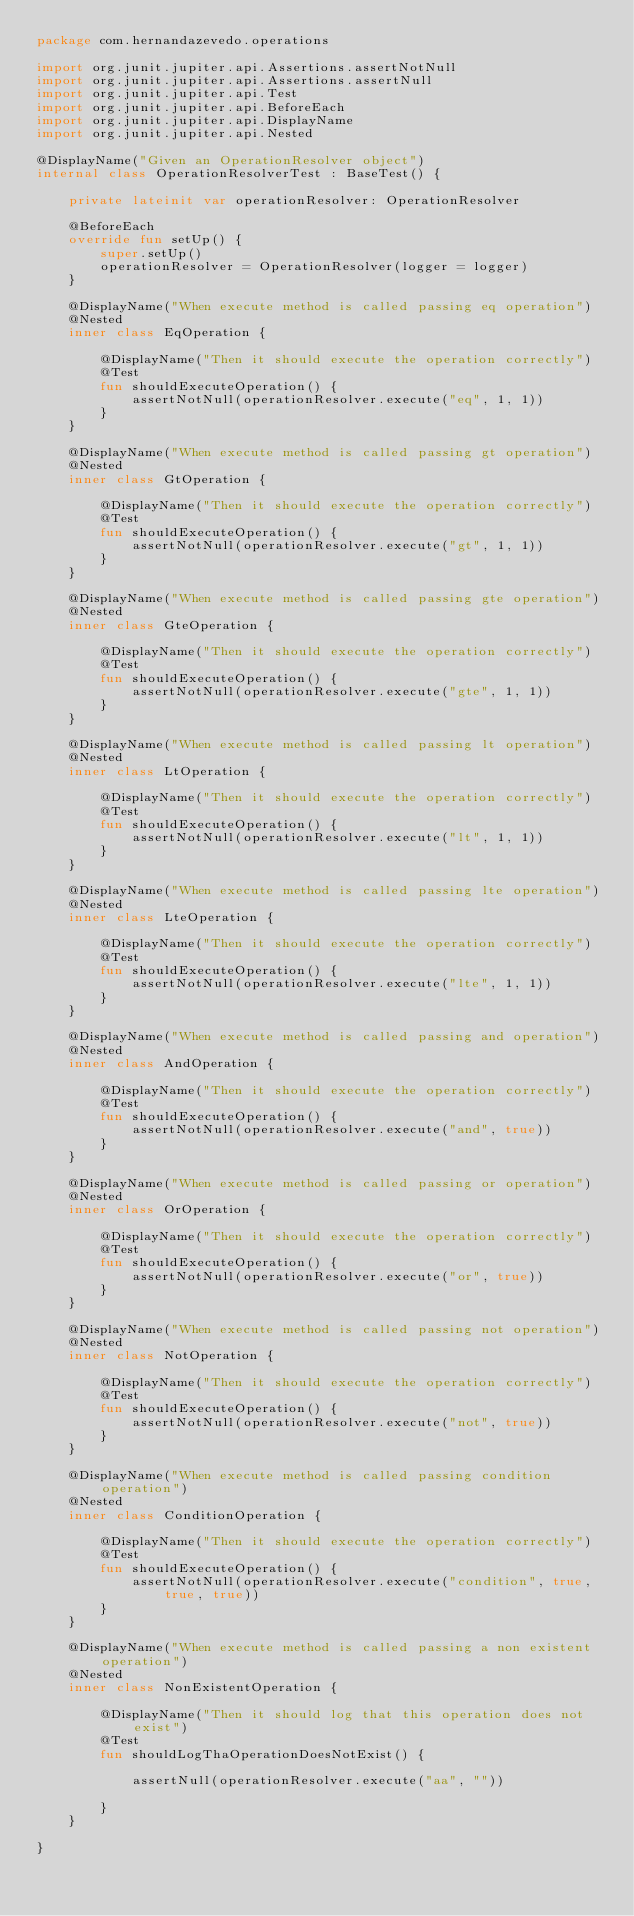<code> <loc_0><loc_0><loc_500><loc_500><_Kotlin_>package com.hernandazevedo.operations

import org.junit.jupiter.api.Assertions.assertNotNull
import org.junit.jupiter.api.Assertions.assertNull
import org.junit.jupiter.api.Test
import org.junit.jupiter.api.BeforeEach
import org.junit.jupiter.api.DisplayName
import org.junit.jupiter.api.Nested

@DisplayName("Given an OperationResolver object")
internal class OperationResolverTest : BaseTest() {

    private lateinit var operationResolver: OperationResolver

    @BeforeEach
    override fun setUp() {
        super.setUp()
        operationResolver = OperationResolver(logger = logger)
    }

    @DisplayName("When execute method is called passing eq operation")
    @Nested
    inner class EqOperation {

        @DisplayName("Then it should execute the operation correctly")
        @Test
        fun shouldExecuteOperation() {
            assertNotNull(operationResolver.execute("eq", 1, 1))
        }
    }

    @DisplayName("When execute method is called passing gt operation")
    @Nested
    inner class GtOperation {

        @DisplayName("Then it should execute the operation correctly")
        @Test
        fun shouldExecuteOperation() {
            assertNotNull(operationResolver.execute("gt", 1, 1))
        }
    }

    @DisplayName("When execute method is called passing gte operation")
    @Nested
    inner class GteOperation {

        @DisplayName("Then it should execute the operation correctly")
        @Test
        fun shouldExecuteOperation() {
            assertNotNull(operationResolver.execute("gte", 1, 1))
        }
    }

    @DisplayName("When execute method is called passing lt operation")
    @Nested
    inner class LtOperation {

        @DisplayName("Then it should execute the operation correctly")
        @Test
        fun shouldExecuteOperation() {
            assertNotNull(operationResolver.execute("lt", 1, 1))
        }
    }

    @DisplayName("When execute method is called passing lte operation")
    @Nested
    inner class LteOperation {

        @DisplayName("Then it should execute the operation correctly")
        @Test
        fun shouldExecuteOperation() {
            assertNotNull(operationResolver.execute("lte", 1, 1))
        }
    }

    @DisplayName("When execute method is called passing and operation")
    @Nested
    inner class AndOperation {

        @DisplayName("Then it should execute the operation correctly")
        @Test
        fun shouldExecuteOperation() {
            assertNotNull(operationResolver.execute("and", true))
        }
    }

    @DisplayName("When execute method is called passing or operation")
    @Nested
    inner class OrOperation {

        @DisplayName("Then it should execute the operation correctly")
        @Test
        fun shouldExecuteOperation() {
            assertNotNull(operationResolver.execute("or", true))
        }
    }

    @DisplayName("When execute method is called passing not operation")
    @Nested
    inner class NotOperation {

        @DisplayName("Then it should execute the operation correctly")
        @Test
        fun shouldExecuteOperation() {
            assertNotNull(operationResolver.execute("not", true))
        }
    }

    @DisplayName("When execute method is called passing condition operation")
    @Nested
    inner class ConditionOperation {

        @DisplayName("Then it should execute the operation correctly")
        @Test
        fun shouldExecuteOperation() {
            assertNotNull(operationResolver.execute("condition", true, true, true))
        }
    }

    @DisplayName("When execute method is called passing a non existent operation")
    @Nested
    inner class NonExistentOperation {

        @DisplayName("Then it should log that this operation does not exist")
        @Test
        fun shouldLogThaOperationDoesNotExist() {

            assertNull(operationResolver.execute("aa", ""))

        }
    }

}</code> 